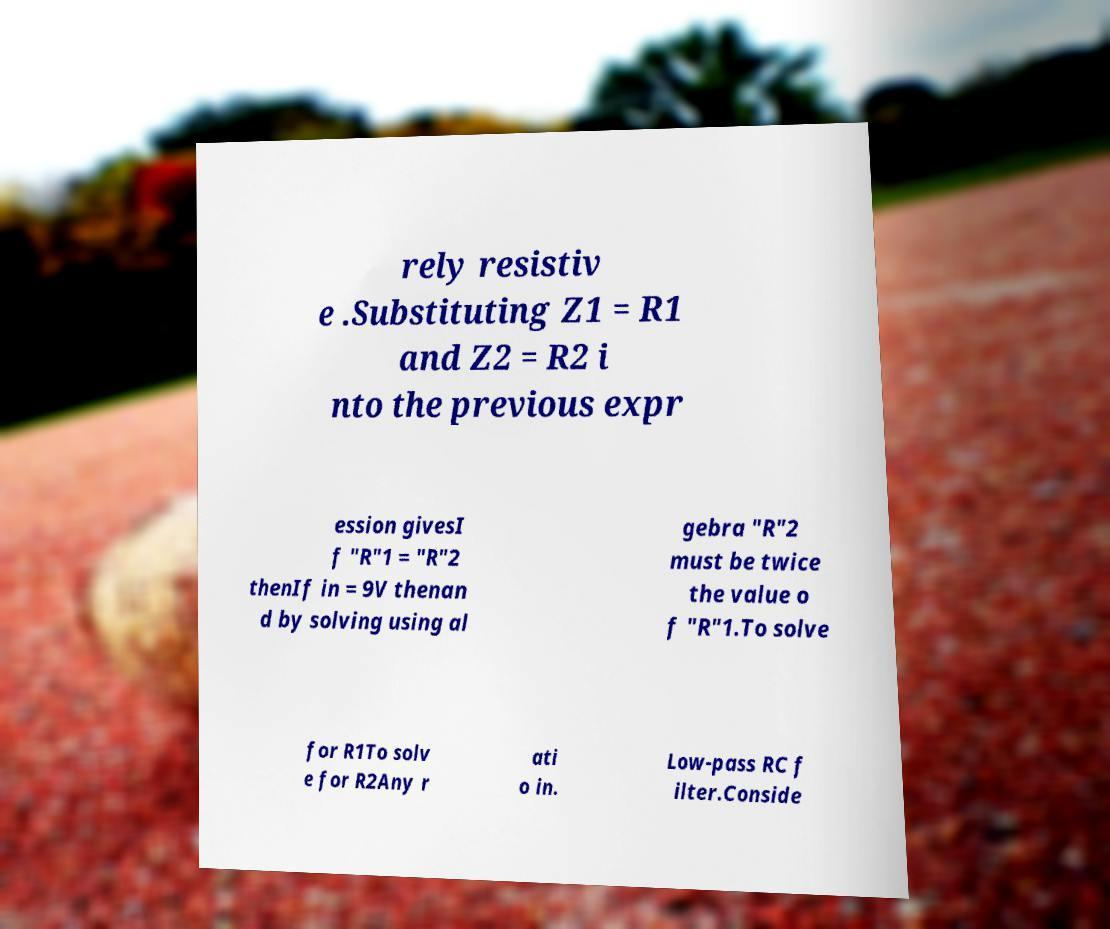What messages or text are displayed in this image? I need them in a readable, typed format. rely resistiv e .Substituting Z1 = R1 and Z2 = R2 i nto the previous expr ession givesI f "R"1 = "R"2 thenIf in = 9V thenan d by solving using al gebra "R"2 must be twice the value o f "R"1.To solve for R1To solv e for R2Any r ati o in. Low-pass RC f ilter.Conside 